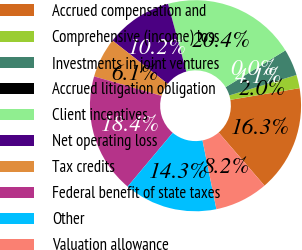Convert chart to OTSL. <chart><loc_0><loc_0><loc_500><loc_500><pie_chart><fcel>Accrued compensation and<fcel>Comprehensive (income) loss<fcel>Investments in joint ventures<fcel>Accrued litigation obligation<fcel>Client incentives<fcel>Net operating loss<fcel>Tax credits<fcel>Federal benefit of state taxes<fcel>Other<fcel>Valuation allowance<nl><fcel>16.32%<fcel>2.04%<fcel>4.08%<fcel>0.0%<fcel>20.4%<fcel>10.2%<fcel>6.12%<fcel>18.36%<fcel>14.28%<fcel>8.16%<nl></chart> 